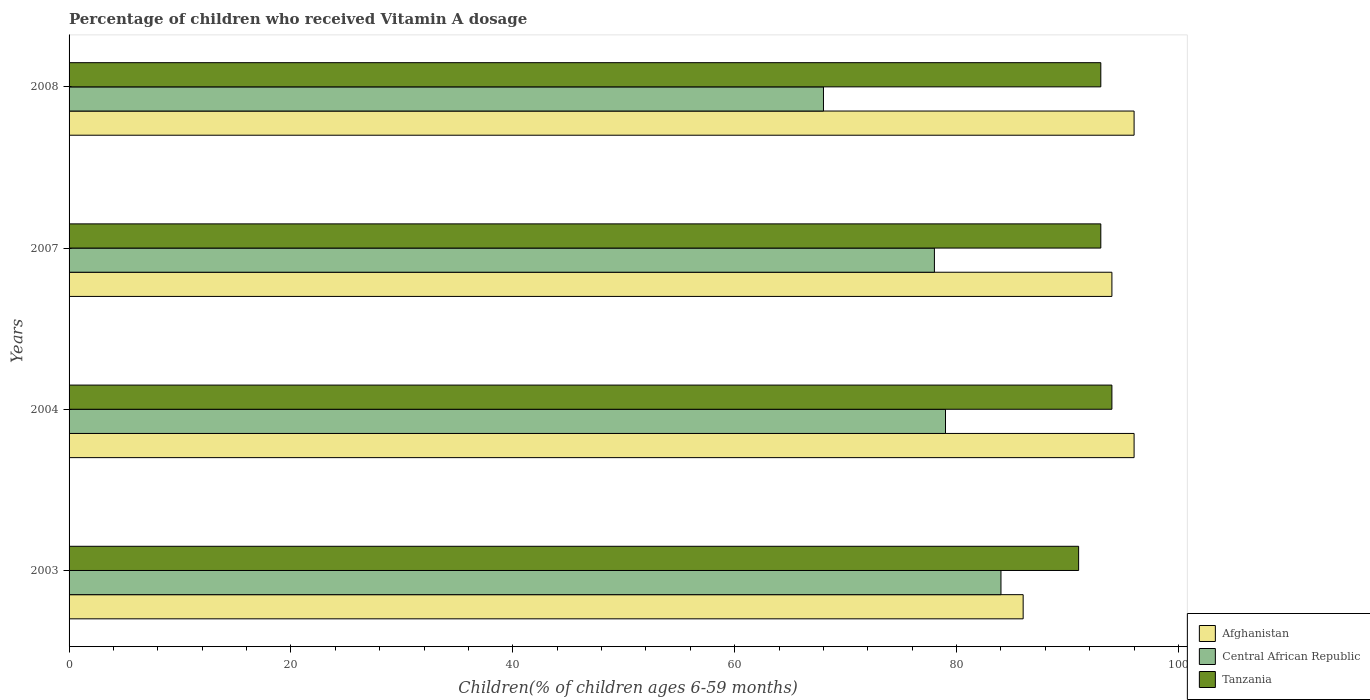Are the number of bars per tick equal to the number of legend labels?
Make the answer very short. Yes. Are the number of bars on each tick of the Y-axis equal?
Make the answer very short. Yes. How many bars are there on the 2nd tick from the top?
Make the answer very short. 3. How many bars are there on the 2nd tick from the bottom?
Provide a succinct answer. 3. What is the label of the 3rd group of bars from the top?
Your answer should be compact. 2004. Across all years, what is the maximum percentage of children who received Vitamin A dosage in Afghanistan?
Provide a succinct answer. 96. Across all years, what is the minimum percentage of children who received Vitamin A dosage in Afghanistan?
Offer a very short reply. 86. In which year was the percentage of children who received Vitamin A dosage in Tanzania maximum?
Give a very brief answer. 2004. In which year was the percentage of children who received Vitamin A dosage in Central African Republic minimum?
Provide a short and direct response. 2008. What is the total percentage of children who received Vitamin A dosage in Tanzania in the graph?
Give a very brief answer. 371. What is the difference between the percentage of children who received Vitamin A dosage in Afghanistan in 2003 and that in 2007?
Your answer should be very brief. -8. What is the difference between the percentage of children who received Vitamin A dosage in Central African Republic in 2004 and the percentage of children who received Vitamin A dosage in Tanzania in 2008?
Make the answer very short. -14. What is the average percentage of children who received Vitamin A dosage in Afghanistan per year?
Your answer should be very brief. 93. What is the ratio of the percentage of children who received Vitamin A dosage in Afghanistan in 2004 to that in 2007?
Provide a succinct answer. 1.02. In how many years, is the percentage of children who received Vitamin A dosage in Central African Republic greater than the average percentage of children who received Vitamin A dosage in Central African Republic taken over all years?
Provide a short and direct response. 3. What does the 1st bar from the top in 2007 represents?
Give a very brief answer. Tanzania. What does the 1st bar from the bottom in 2007 represents?
Provide a short and direct response. Afghanistan. Is it the case that in every year, the sum of the percentage of children who received Vitamin A dosage in Tanzania and percentage of children who received Vitamin A dosage in Central African Republic is greater than the percentage of children who received Vitamin A dosage in Afghanistan?
Your answer should be very brief. Yes. Are the values on the major ticks of X-axis written in scientific E-notation?
Ensure brevity in your answer.  No. Does the graph contain any zero values?
Keep it short and to the point. No. How are the legend labels stacked?
Keep it short and to the point. Vertical. What is the title of the graph?
Your answer should be very brief. Percentage of children who received Vitamin A dosage. What is the label or title of the X-axis?
Make the answer very short. Children(% of children ages 6-59 months). What is the Children(% of children ages 6-59 months) in Central African Republic in 2003?
Keep it short and to the point. 84. What is the Children(% of children ages 6-59 months) of Tanzania in 2003?
Offer a very short reply. 91. What is the Children(% of children ages 6-59 months) of Afghanistan in 2004?
Your answer should be compact. 96. What is the Children(% of children ages 6-59 months) of Central African Republic in 2004?
Your response must be concise. 79. What is the Children(% of children ages 6-59 months) of Tanzania in 2004?
Your answer should be compact. 94. What is the Children(% of children ages 6-59 months) in Afghanistan in 2007?
Provide a short and direct response. 94. What is the Children(% of children ages 6-59 months) of Central African Republic in 2007?
Provide a succinct answer. 78. What is the Children(% of children ages 6-59 months) of Tanzania in 2007?
Your answer should be very brief. 93. What is the Children(% of children ages 6-59 months) of Afghanistan in 2008?
Offer a terse response. 96. What is the Children(% of children ages 6-59 months) in Tanzania in 2008?
Your answer should be compact. 93. Across all years, what is the maximum Children(% of children ages 6-59 months) of Afghanistan?
Keep it short and to the point. 96. Across all years, what is the maximum Children(% of children ages 6-59 months) in Central African Republic?
Offer a terse response. 84. Across all years, what is the maximum Children(% of children ages 6-59 months) of Tanzania?
Your answer should be compact. 94. Across all years, what is the minimum Children(% of children ages 6-59 months) of Afghanistan?
Offer a very short reply. 86. Across all years, what is the minimum Children(% of children ages 6-59 months) in Central African Republic?
Provide a succinct answer. 68. Across all years, what is the minimum Children(% of children ages 6-59 months) of Tanzania?
Ensure brevity in your answer.  91. What is the total Children(% of children ages 6-59 months) in Afghanistan in the graph?
Make the answer very short. 372. What is the total Children(% of children ages 6-59 months) of Central African Republic in the graph?
Make the answer very short. 309. What is the total Children(% of children ages 6-59 months) in Tanzania in the graph?
Offer a terse response. 371. What is the difference between the Children(% of children ages 6-59 months) of Central African Republic in 2003 and that in 2004?
Ensure brevity in your answer.  5. What is the difference between the Children(% of children ages 6-59 months) in Afghanistan in 2003 and that in 2007?
Your answer should be very brief. -8. What is the difference between the Children(% of children ages 6-59 months) in Tanzania in 2003 and that in 2007?
Keep it short and to the point. -2. What is the difference between the Children(% of children ages 6-59 months) in Afghanistan in 2003 and that in 2008?
Ensure brevity in your answer.  -10. What is the difference between the Children(% of children ages 6-59 months) of Central African Republic in 2003 and that in 2008?
Make the answer very short. 16. What is the difference between the Children(% of children ages 6-59 months) in Central African Republic in 2004 and that in 2007?
Your answer should be compact. 1. What is the difference between the Children(% of children ages 6-59 months) in Afghanistan in 2004 and that in 2008?
Offer a terse response. 0. What is the difference between the Children(% of children ages 6-59 months) of Central African Republic in 2007 and that in 2008?
Ensure brevity in your answer.  10. What is the difference between the Children(% of children ages 6-59 months) of Afghanistan in 2003 and the Children(% of children ages 6-59 months) of Central African Republic in 2004?
Make the answer very short. 7. What is the difference between the Children(% of children ages 6-59 months) in Central African Republic in 2003 and the Children(% of children ages 6-59 months) in Tanzania in 2007?
Provide a short and direct response. -9. What is the difference between the Children(% of children ages 6-59 months) in Afghanistan in 2003 and the Children(% of children ages 6-59 months) in Central African Republic in 2008?
Your response must be concise. 18. What is the difference between the Children(% of children ages 6-59 months) in Afghanistan in 2003 and the Children(% of children ages 6-59 months) in Tanzania in 2008?
Ensure brevity in your answer.  -7. What is the difference between the Children(% of children ages 6-59 months) in Afghanistan in 2004 and the Children(% of children ages 6-59 months) in Tanzania in 2007?
Your response must be concise. 3. What is the difference between the Children(% of children ages 6-59 months) of Afghanistan in 2004 and the Children(% of children ages 6-59 months) of Central African Republic in 2008?
Your answer should be very brief. 28. What is the difference between the Children(% of children ages 6-59 months) in Afghanistan in 2004 and the Children(% of children ages 6-59 months) in Tanzania in 2008?
Offer a terse response. 3. What is the difference between the Children(% of children ages 6-59 months) in Afghanistan in 2007 and the Children(% of children ages 6-59 months) in Tanzania in 2008?
Make the answer very short. 1. What is the difference between the Children(% of children ages 6-59 months) in Central African Republic in 2007 and the Children(% of children ages 6-59 months) in Tanzania in 2008?
Offer a terse response. -15. What is the average Children(% of children ages 6-59 months) in Afghanistan per year?
Your response must be concise. 93. What is the average Children(% of children ages 6-59 months) in Central African Republic per year?
Ensure brevity in your answer.  77.25. What is the average Children(% of children ages 6-59 months) in Tanzania per year?
Provide a succinct answer. 92.75. In the year 2003, what is the difference between the Children(% of children ages 6-59 months) in Central African Republic and Children(% of children ages 6-59 months) in Tanzania?
Keep it short and to the point. -7. In the year 2004, what is the difference between the Children(% of children ages 6-59 months) of Afghanistan and Children(% of children ages 6-59 months) of Central African Republic?
Offer a very short reply. 17. In the year 2004, what is the difference between the Children(% of children ages 6-59 months) of Afghanistan and Children(% of children ages 6-59 months) of Tanzania?
Keep it short and to the point. 2. In the year 2007, what is the difference between the Children(% of children ages 6-59 months) of Afghanistan and Children(% of children ages 6-59 months) of Central African Republic?
Ensure brevity in your answer.  16. In the year 2007, what is the difference between the Children(% of children ages 6-59 months) of Afghanistan and Children(% of children ages 6-59 months) of Tanzania?
Your answer should be very brief. 1. In the year 2007, what is the difference between the Children(% of children ages 6-59 months) of Central African Republic and Children(% of children ages 6-59 months) of Tanzania?
Keep it short and to the point. -15. In the year 2008, what is the difference between the Children(% of children ages 6-59 months) of Afghanistan and Children(% of children ages 6-59 months) of Tanzania?
Your answer should be very brief. 3. In the year 2008, what is the difference between the Children(% of children ages 6-59 months) in Central African Republic and Children(% of children ages 6-59 months) in Tanzania?
Offer a terse response. -25. What is the ratio of the Children(% of children ages 6-59 months) of Afghanistan in 2003 to that in 2004?
Offer a terse response. 0.9. What is the ratio of the Children(% of children ages 6-59 months) in Central African Republic in 2003 to that in 2004?
Offer a very short reply. 1.06. What is the ratio of the Children(% of children ages 6-59 months) of Tanzania in 2003 to that in 2004?
Offer a terse response. 0.97. What is the ratio of the Children(% of children ages 6-59 months) in Afghanistan in 2003 to that in 2007?
Offer a very short reply. 0.91. What is the ratio of the Children(% of children ages 6-59 months) in Central African Republic in 2003 to that in 2007?
Offer a terse response. 1.08. What is the ratio of the Children(% of children ages 6-59 months) of Tanzania in 2003 to that in 2007?
Keep it short and to the point. 0.98. What is the ratio of the Children(% of children ages 6-59 months) of Afghanistan in 2003 to that in 2008?
Provide a succinct answer. 0.9. What is the ratio of the Children(% of children ages 6-59 months) of Central African Republic in 2003 to that in 2008?
Offer a very short reply. 1.24. What is the ratio of the Children(% of children ages 6-59 months) of Tanzania in 2003 to that in 2008?
Offer a terse response. 0.98. What is the ratio of the Children(% of children ages 6-59 months) in Afghanistan in 2004 to that in 2007?
Your response must be concise. 1.02. What is the ratio of the Children(% of children ages 6-59 months) in Central African Republic in 2004 to that in 2007?
Ensure brevity in your answer.  1.01. What is the ratio of the Children(% of children ages 6-59 months) of Tanzania in 2004 to that in 2007?
Give a very brief answer. 1.01. What is the ratio of the Children(% of children ages 6-59 months) of Central African Republic in 2004 to that in 2008?
Your answer should be very brief. 1.16. What is the ratio of the Children(% of children ages 6-59 months) in Tanzania in 2004 to that in 2008?
Provide a succinct answer. 1.01. What is the ratio of the Children(% of children ages 6-59 months) of Afghanistan in 2007 to that in 2008?
Offer a terse response. 0.98. What is the ratio of the Children(% of children ages 6-59 months) of Central African Republic in 2007 to that in 2008?
Your answer should be compact. 1.15. What is the ratio of the Children(% of children ages 6-59 months) of Tanzania in 2007 to that in 2008?
Provide a succinct answer. 1. What is the difference between the highest and the second highest Children(% of children ages 6-59 months) in Afghanistan?
Give a very brief answer. 0. What is the difference between the highest and the lowest Children(% of children ages 6-59 months) of Tanzania?
Your answer should be very brief. 3. 